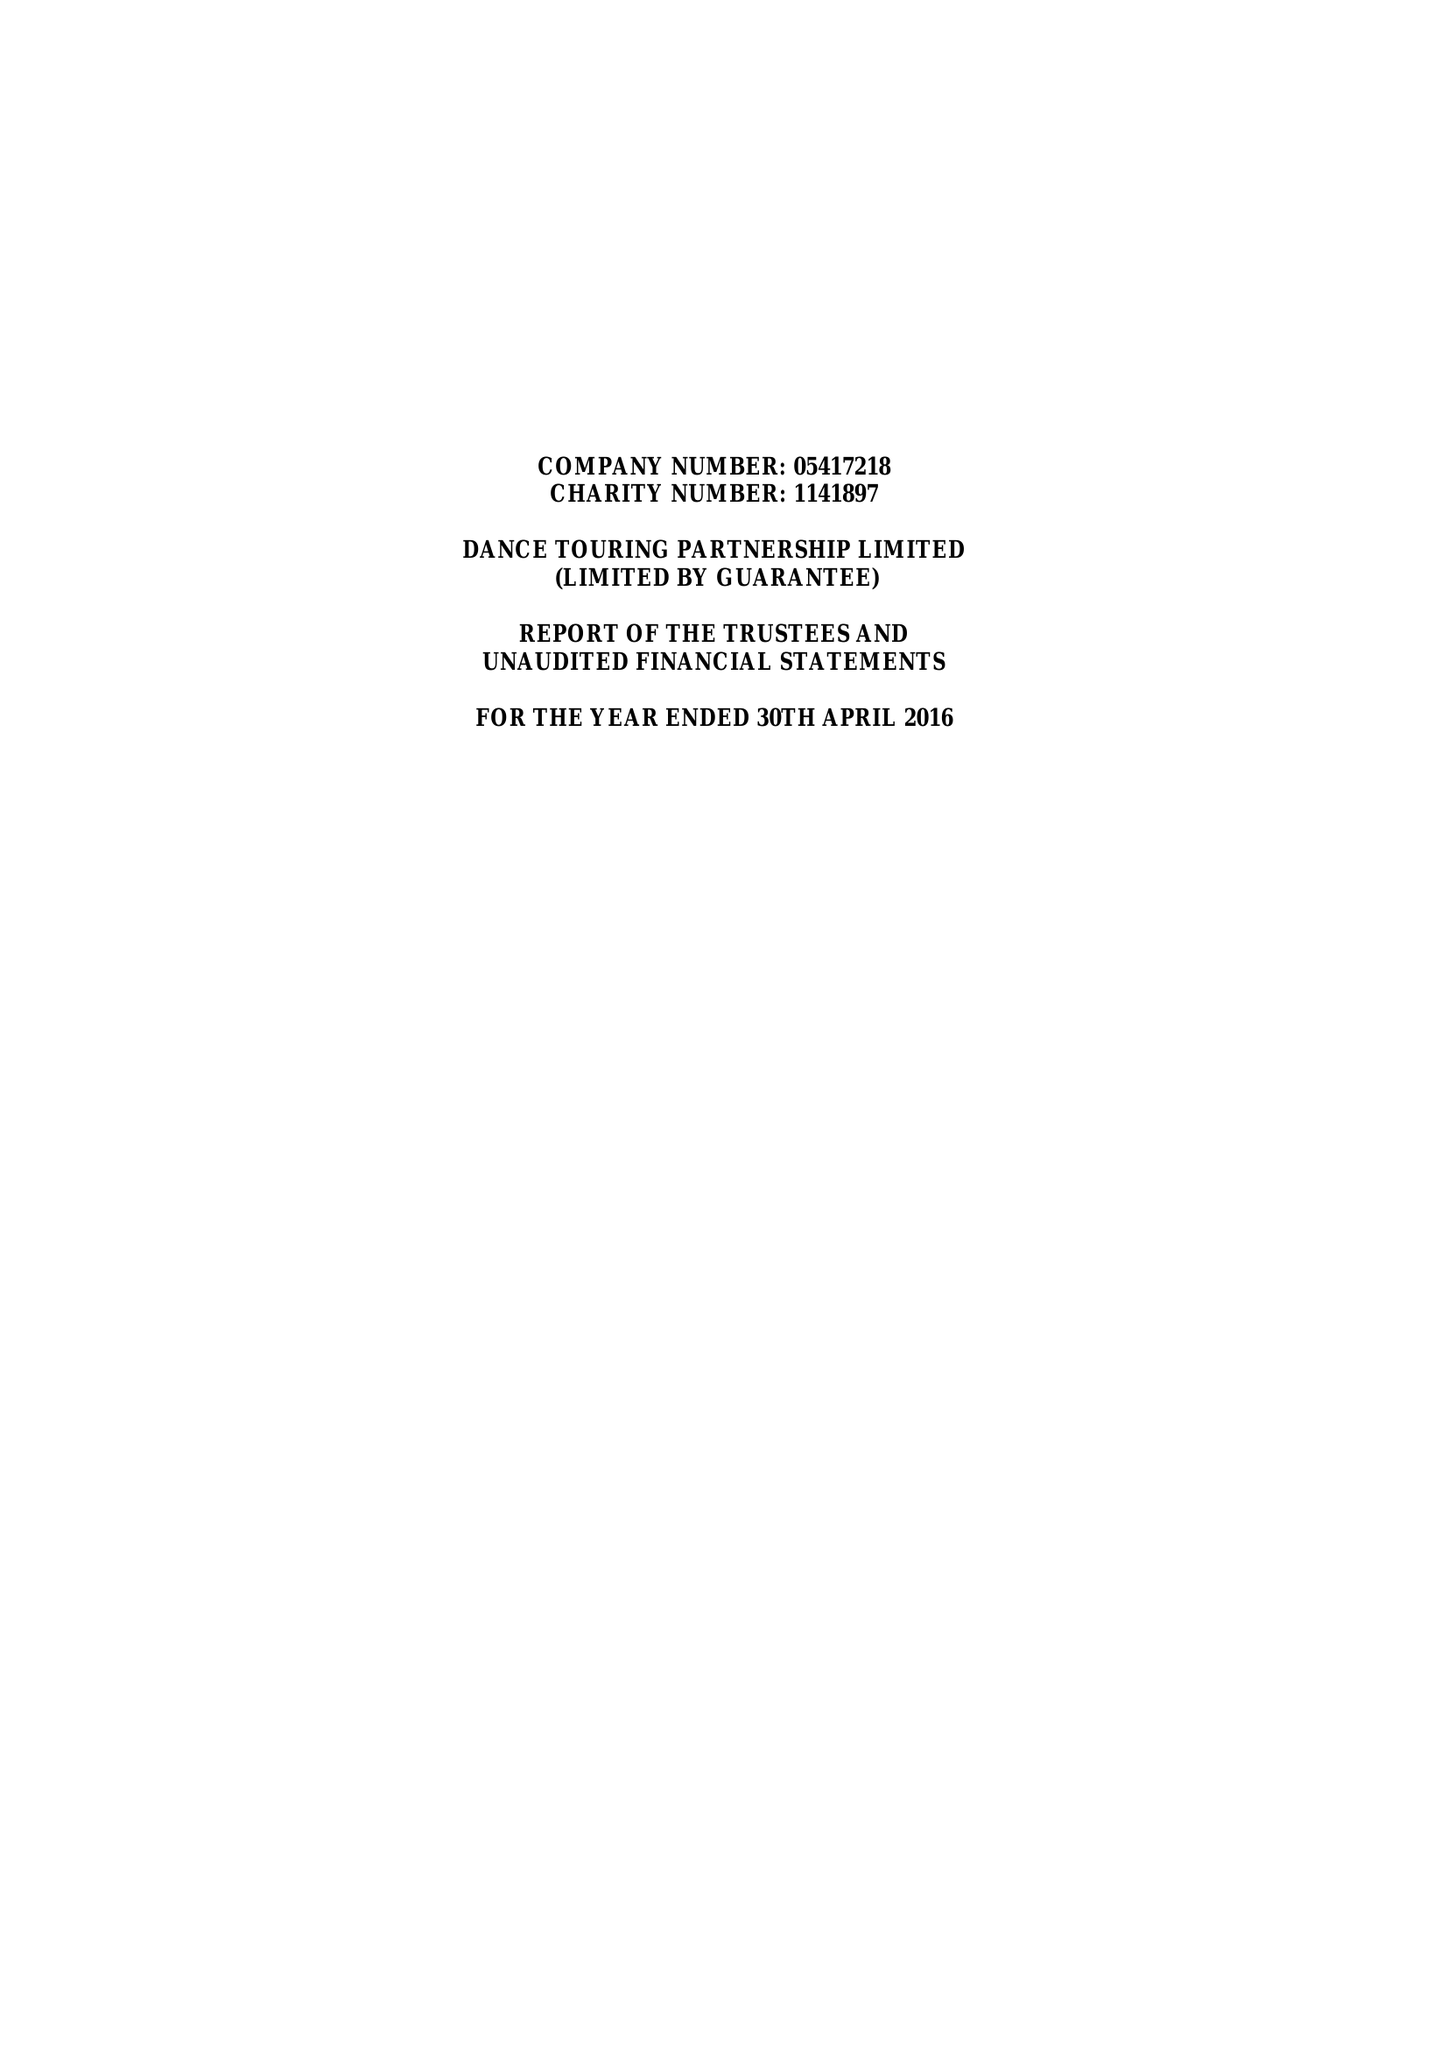What is the value for the address__postcode?
Answer the question using a single word or phrase. S1 4FW 